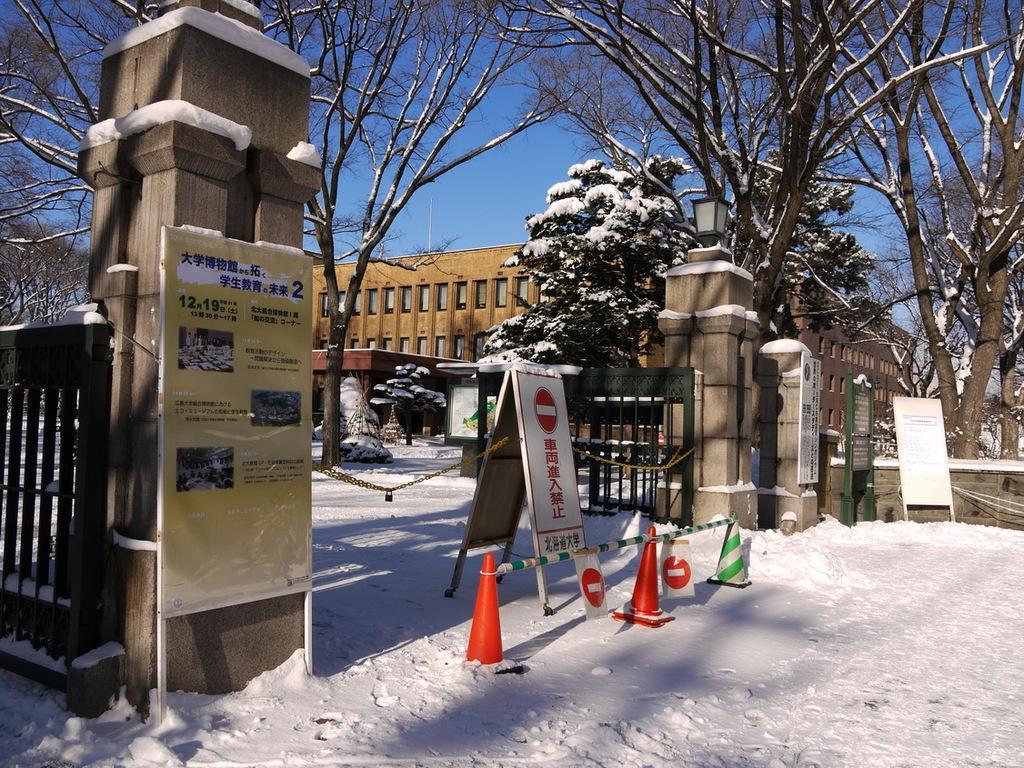Can you describe this image briefly? In this image there is one building at left side of this image and there are some trees in middle of this image and there are some sign boards are kept, as we can see at bottom of this image. 